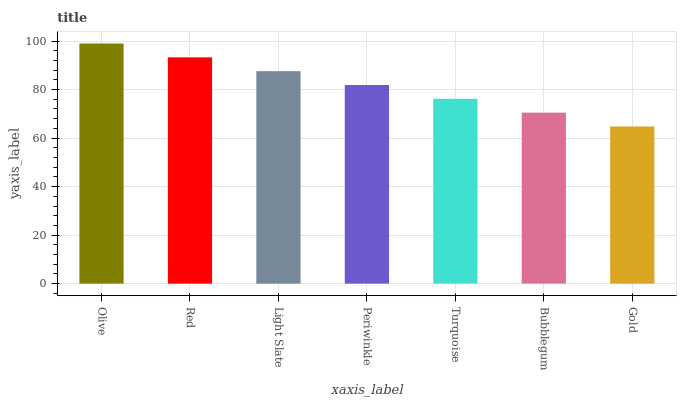Is Gold the minimum?
Answer yes or no. Yes. Is Olive the maximum?
Answer yes or no. Yes. Is Red the minimum?
Answer yes or no. No. Is Red the maximum?
Answer yes or no. No. Is Olive greater than Red?
Answer yes or no. Yes. Is Red less than Olive?
Answer yes or no. Yes. Is Red greater than Olive?
Answer yes or no. No. Is Olive less than Red?
Answer yes or no. No. Is Periwinkle the high median?
Answer yes or no. Yes. Is Periwinkle the low median?
Answer yes or no. Yes. Is Turquoise the high median?
Answer yes or no. No. Is Turquoise the low median?
Answer yes or no. No. 